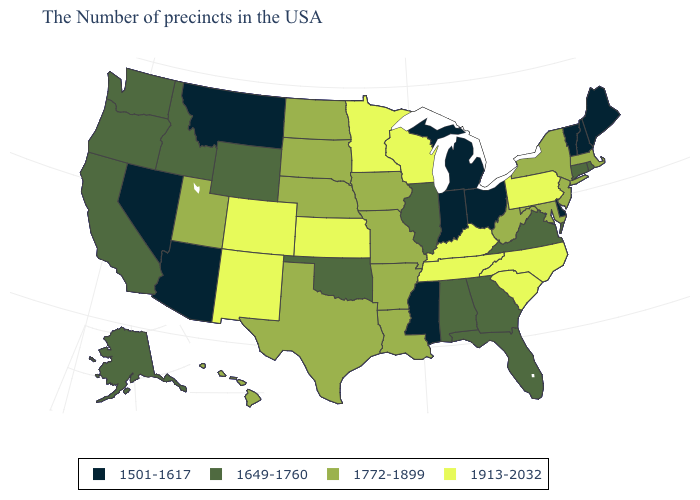Does Delaware have the same value as New Hampshire?
Answer briefly. Yes. Does the first symbol in the legend represent the smallest category?
Short answer required. Yes. Among the states that border New York , which have the highest value?
Answer briefly. Pennsylvania. Name the states that have a value in the range 1913-2032?
Be succinct. Pennsylvania, North Carolina, South Carolina, Kentucky, Tennessee, Wisconsin, Minnesota, Kansas, Colorado, New Mexico. Name the states that have a value in the range 1501-1617?
Be succinct. Maine, New Hampshire, Vermont, Delaware, Ohio, Michigan, Indiana, Mississippi, Montana, Arizona, Nevada. Among the states that border Georgia , does Florida have the lowest value?
Concise answer only. Yes. Does the map have missing data?
Concise answer only. No. What is the highest value in the South ?
Concise answer only. 1913-2032. Name the states that have a value in the range 1501-1617?
Keep it brief. Maine, New Hampshire, Vermont, Delaware, Ohio, Michigan, Indiana, Mississippi, Montana, Arizona, Nevada. What is the lowest value in the MidWest?
Be succinct. 1501-1617. Does West Virginia have the highest value in the South?
Answer briefly. No. Which states have the lowest value in the USA?
Be succinct. Maine, New Hampshire, Vermont, Delaware, Ohio, Michigan, Indiana, Mississippi, Montana, Arizona, Nevada. Name the states that have a value in the range 1501-1617?
Be succinct. Maine, New Hampshire, Vermont, Delaware, Ohio, Michigan, Indiana, Mississippi, Montana, Arizona, Nevada. Among the states that border Alabama , does Georgia have the lowest value?
Answer briefly. No. What is the highest value in the South ?
Give a very brief answer. 1913-2032. 